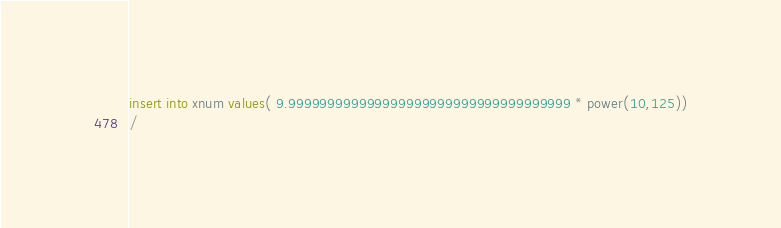Convert code to text. <code><loc_0><loc_0><loc_500><loc_500><_SQL_>
insert into xnum values( 9.999999999999999999999999999999999999 * power(10,125))
/

</code> 